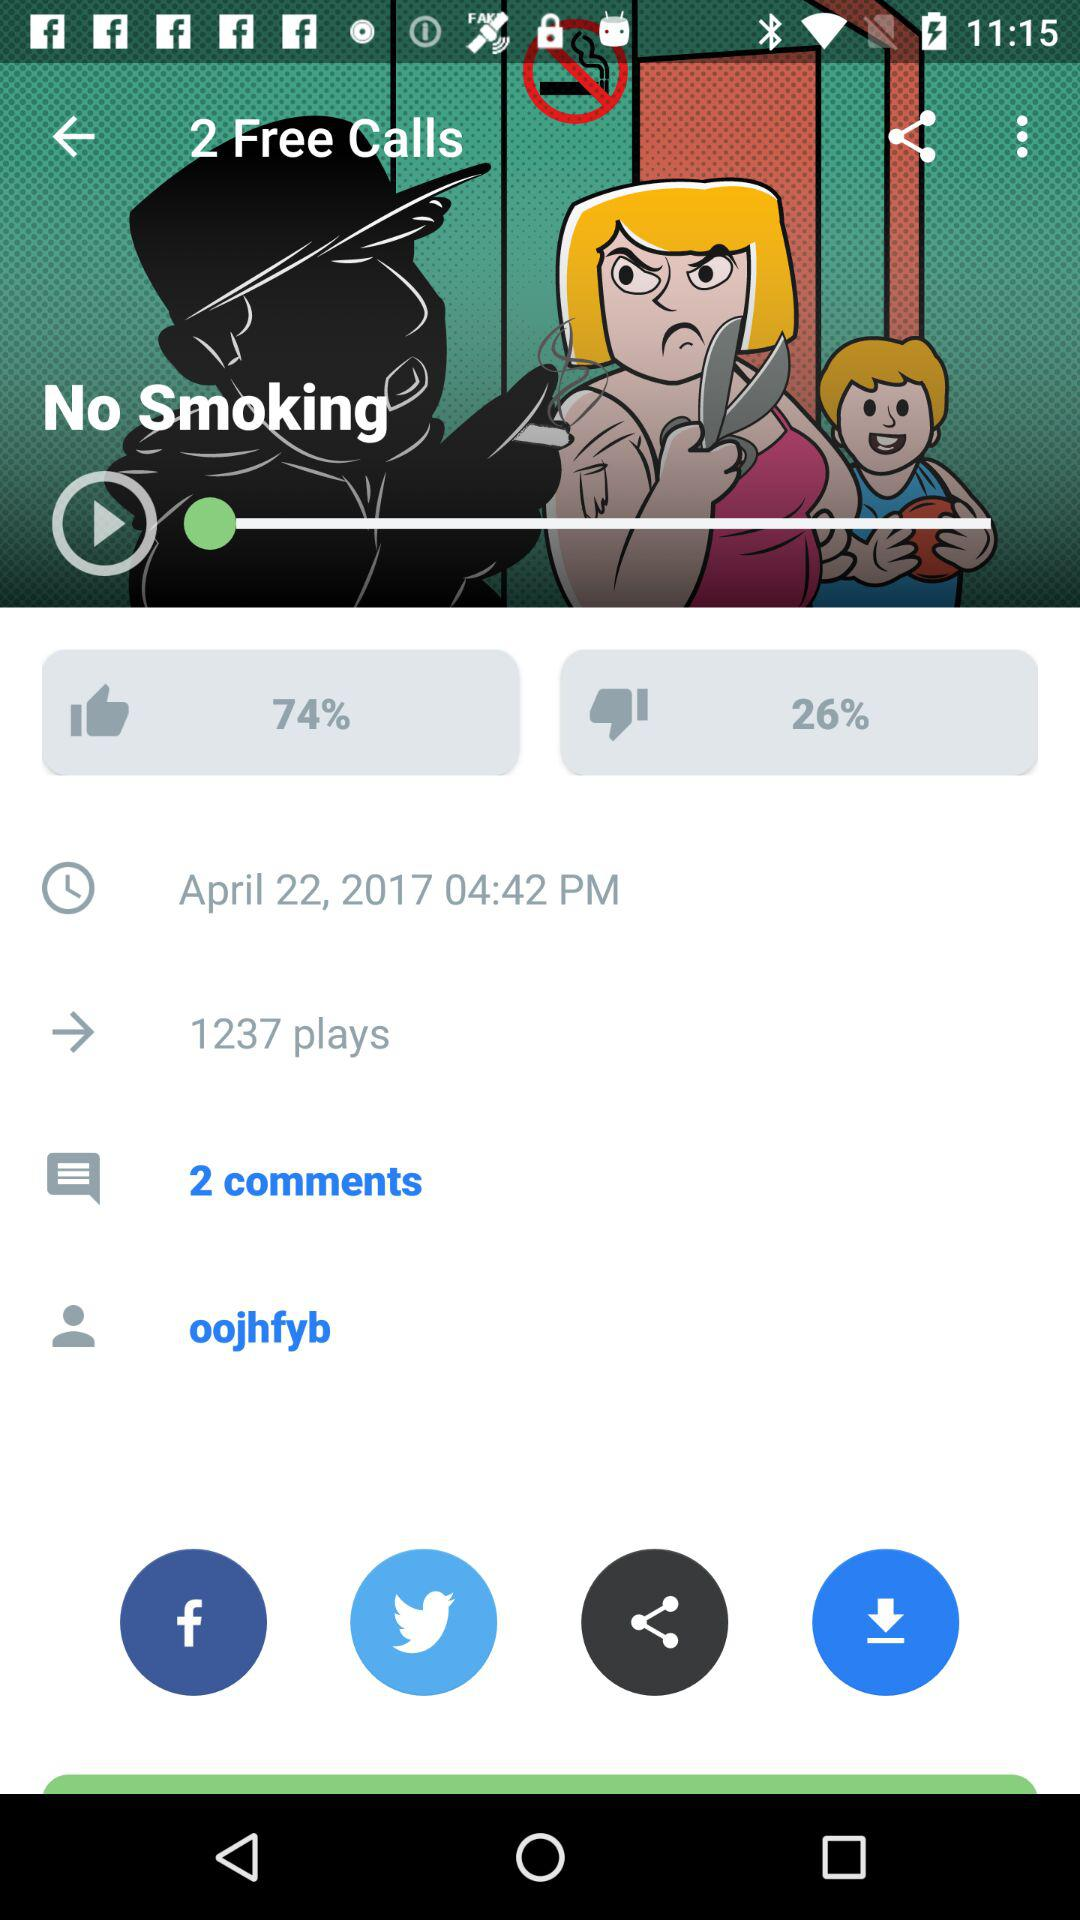What is the shown dislike percentage? The shown dislike percentage is 26. 